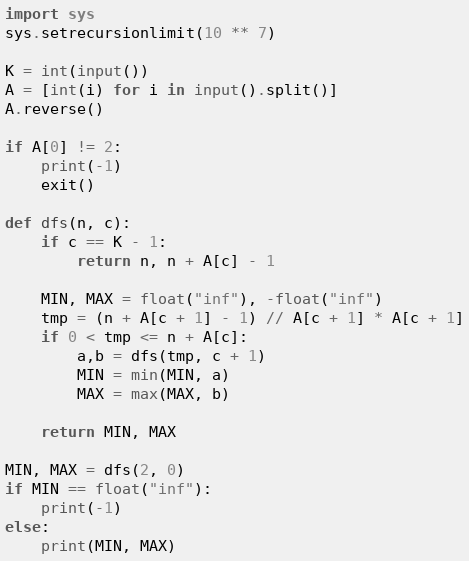<code> <loc_0><loc_0><loc_500><loc_500><_Python_>import sys
sys.setrecursionlimit(10 ** 7)

K = int(input())
A = [int(i) for i in input().split()]
A.reverse()

if A[0] != 2:
    print(-1)
    exit()

def dfs(n, c):
    if c == K - 1:
        return n, n + A[c] - 1

    MIN, MAX = float("inf"), -float("inf")
    tmp = (n + A[c + 1] - 1) // A[c + 1] * A[c + 1]
    if 0 < tmp <= n + A[c]:
        a,b = dfs(tmp, c + 1)
        MIN = min(MIN, a)
        MAX = max(MAX, b)
    
    return MIN, MAX

MIN, MAX = dfs(2, 0)
if MIN == float("inf"):
    print(-1)
else:
    print(MIN, MAX)</code> 